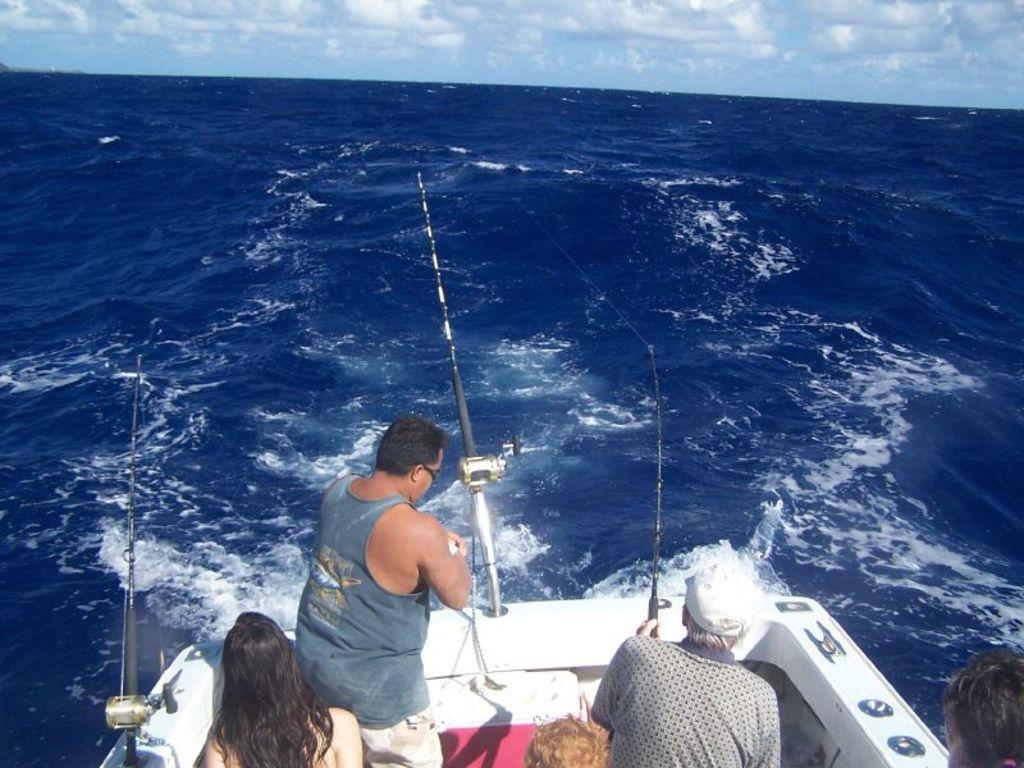Can you describe this image briefly? In this image I can see five people standing in a boat facing towards the back among them one person is holding a fishing rod there are two more fishing rods kept on the edge of the boat. I can see the sea in the center of the image. At the top of the image I can see the sky. 